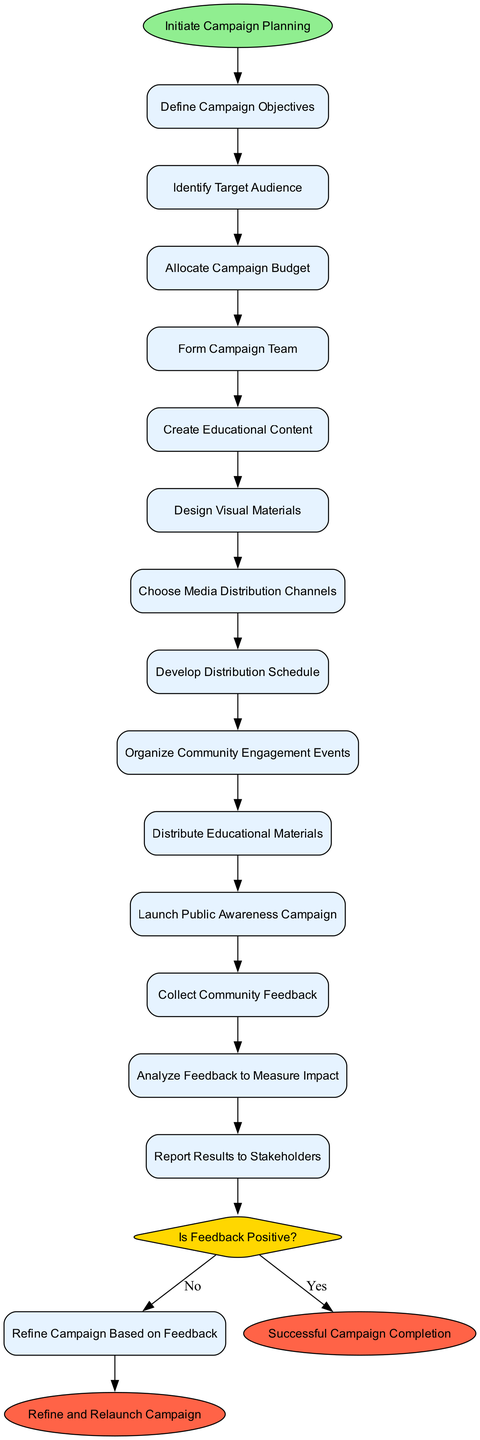What is the first activity in the campaign planning? The diagram starts with the node labeled "Initiate Campaign Planning," which leads to the first activity, "Define Campaign Objectives." Therefore, the first activity is "Define Campaign Objectives."
Answer: Define Campaign Objectives How many activities are included in the campaign? There are a total of 13 activities listed in the diagram, from "Define Campaign Objectives" to "Refine Campaign Based on Feedback." Counting these gives us 13 activities.
Answer: 13 What is the last decision point in the flow? The last decision point in the diagram is "Is Feedback Positive?" This is where the next steps are determined based on the feedback received.
Answer: Is Feedback Positive? What is the outcome if the feedback is positive? According to the diagram, if the feedback is positive, the process leads directly to the end event "Successful Campaign Completion."
Answer: Successful Campaign Completion What activity follows collecting community feedback? The activity that comes after "Collect Community Feedback" is "Analyze Feedback to Measure Impact." This indicates the process flow after gathering feedback.
Answer: Analyze Feedback to Measure Impact What are the two possible outcomes from the feedback analysis? The feedback analysis leads to two outcomes: if the feedback is positive, it goes to "Successful Campaign Completion," and if it's not, it leads to "Refine Campaign Based on Feedback."
Answer: Successful Campaign Completion and Refine Campaign Based on Feedback Which activity involves directly interacting with the community? The activity labeled "Organize Community Engagement Events" specifically involves direct interaction with the community, as it is focused on engagement efforts.
Answer: Organize Community Engagement Events How many end events are defined in the diagram? The diagram specifies two end events: "Successful Campaign Completion" and "Refine and Relaunch Campaign." Thus, there are 2 defined end events.
Answer: 2 